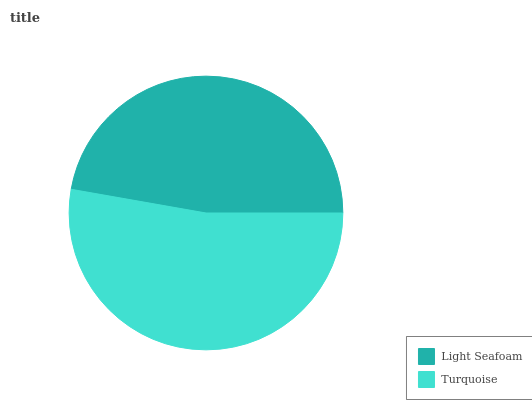Is Light Seafoam the minimum?
Answer yes or no. Yes. Is Turquoise the maximum?
Answer yes or no. Yes. Is Turquoise the minimum?
Answer yes or no. No. Is Turquoise greater than Light Seafoam?
Answer yes or no. Yes. Is Light Seafoam less than Turquoise?
Answer yes or no. Yes. Is Light Seafoam greater than Turquoise?
Answer yes or no. No. Is Turquoise less than Light Seafoam?
Answer yes or no. No. Is Turquoise the high median?
Answer yes or no. Yes. Is Light Seafoam the low median?
Answer yes or no. Yes. Is Light Seafoam the high median?
Answer yes or no. No. Is Turquoise the low median?
Answer yes or no. No. 